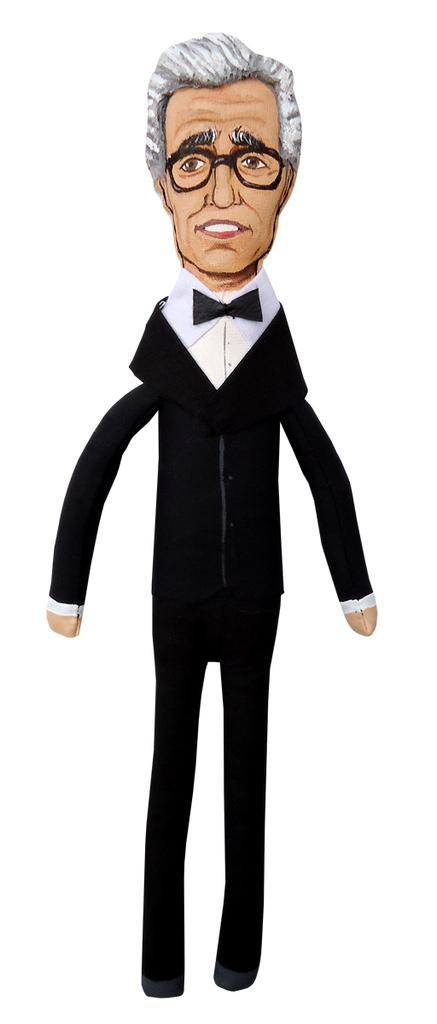What is the main subject of the image? There is a person in the image. What can be observed about the person's appearance? The person is wearing specs and a black suit. What is the color of the background in the image? The background of the image is white. What theory is the person discussing in the image? There is no indication in the image that the person is discussing any theory. Can you see the person biting into something in the image? There is no food or object present in the image that would suggest the person is biting into anything. 